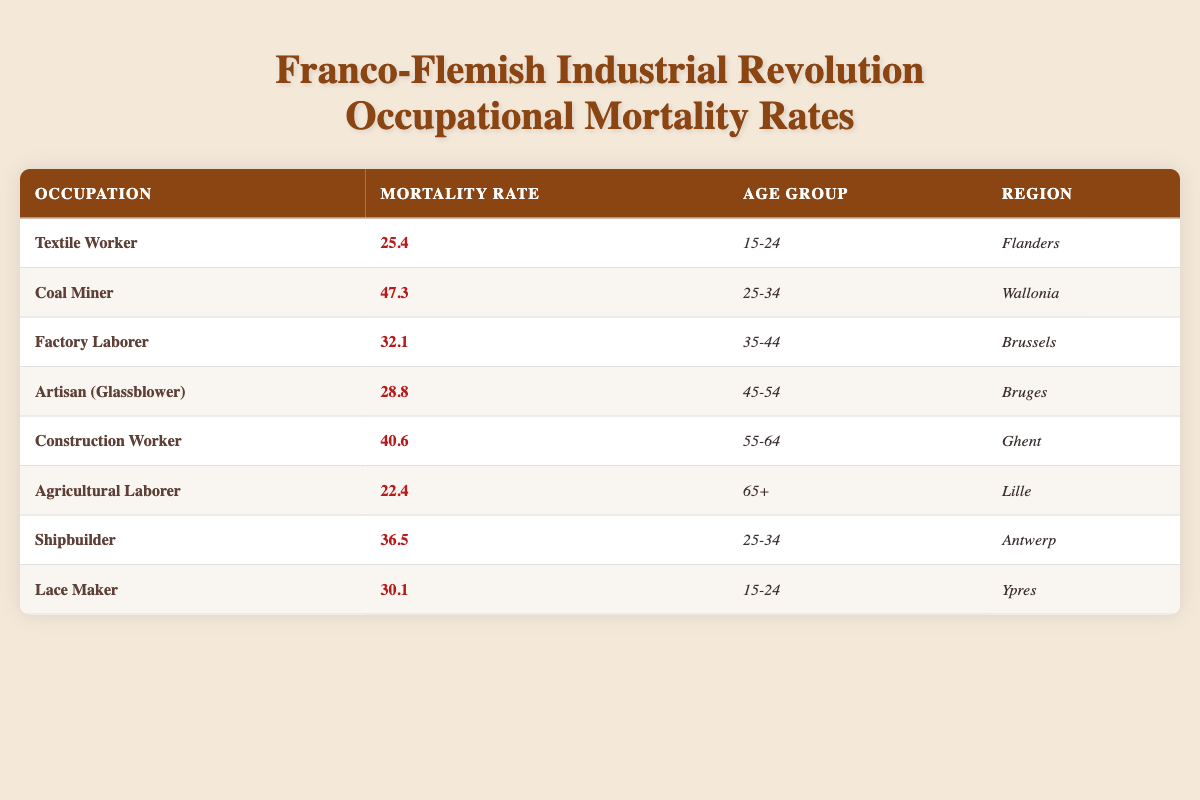What is the highest mortality rate among the listed occupations? By examining the table, I can see the listed mortality rates. The highest value is 47.3, which corresponds to the occupation of Coal Miner in the age group 25-34 in Wallonia.
Answer: 47.3 Which occupation has the lowest mortality rate and where is it located? The occupation with the lowest mortality rate is Agricultural Laborer, which has a mortality rate of 22.4 in the region of Lille for the age group 65+.
Answer: Agricultural Laborer in Lille How many regions are represented in the table? The regions represented are Flanders, Wallonia, Brussels, Bruges, Ghent, Lille, Antwerp, and Ypres. This totals to 8 unique regions.
Answer: 8 What is the average mortality rate for all occupations listed? The mortality rates are as follows: 25.4, 47.3, 32.1, 28.8, 40.6, 22.4, 36.5, and 30.1. Adding them gives 263.8, and there are 8 occupations. Therefore, the average mortality rate is 263.8 / 8 = 32.975.
Answer: 32.975 Is the mortality rate for Textile Workers higher than that of Lace Makers? The mortality rate for Textile Workers is 25.4 while for Lace Makers it is 30.1. Since 25.4 is less than 30.1, the statement is false.
Answer: No How many occupations have a mortality rate greater than 30? The occupations with a mortality rate greater than 30 are Coal Miner (47.3), Factory Laborer (32.1), Shipbuilder (36.5), and Construction Worker (40.6). This totals 4 occupations.
Answer: 4 What is the mortality rate difference between the Construction Worker and the Factory Laborer? The mortality rate for Construction Workers is 40.6 and for Factory Laborers it is 32.1. The difference can be calculated as 40.6 - 32.1 = 8.5.
Answer: 8.5 Which age group has the highest mortality rates in the table? The age groups listed are 15-24, 25-34, 35-44, 45-54, 55-64, and 65+. Upon checking, the highest rate is for Coal Miners at 47.3 for the age group 25-34.
Answer: 25-34 